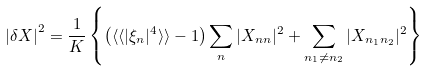Convert formula to latex. <formula><loc_0><loc_0><loc_500><loc_500>\left | \delta X \right | ^ { 2 } = \frac { 1 } { K } \left \{ \left ( \langle \langle | \xi _ { n } | ^ { 4 } \rangle \rangle - 1 \right ) \sum _ { n } | X _ { n n } | ^ { 2 } + \sum _ { n _ { 1 } \ne n _ { 2 } } | X _ { n _ { 1 } n _ { 2 } } | ^ { 2 } \right \}</formula> 